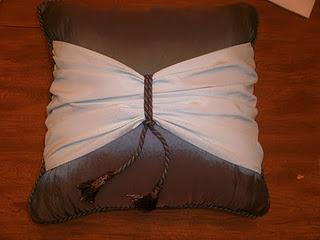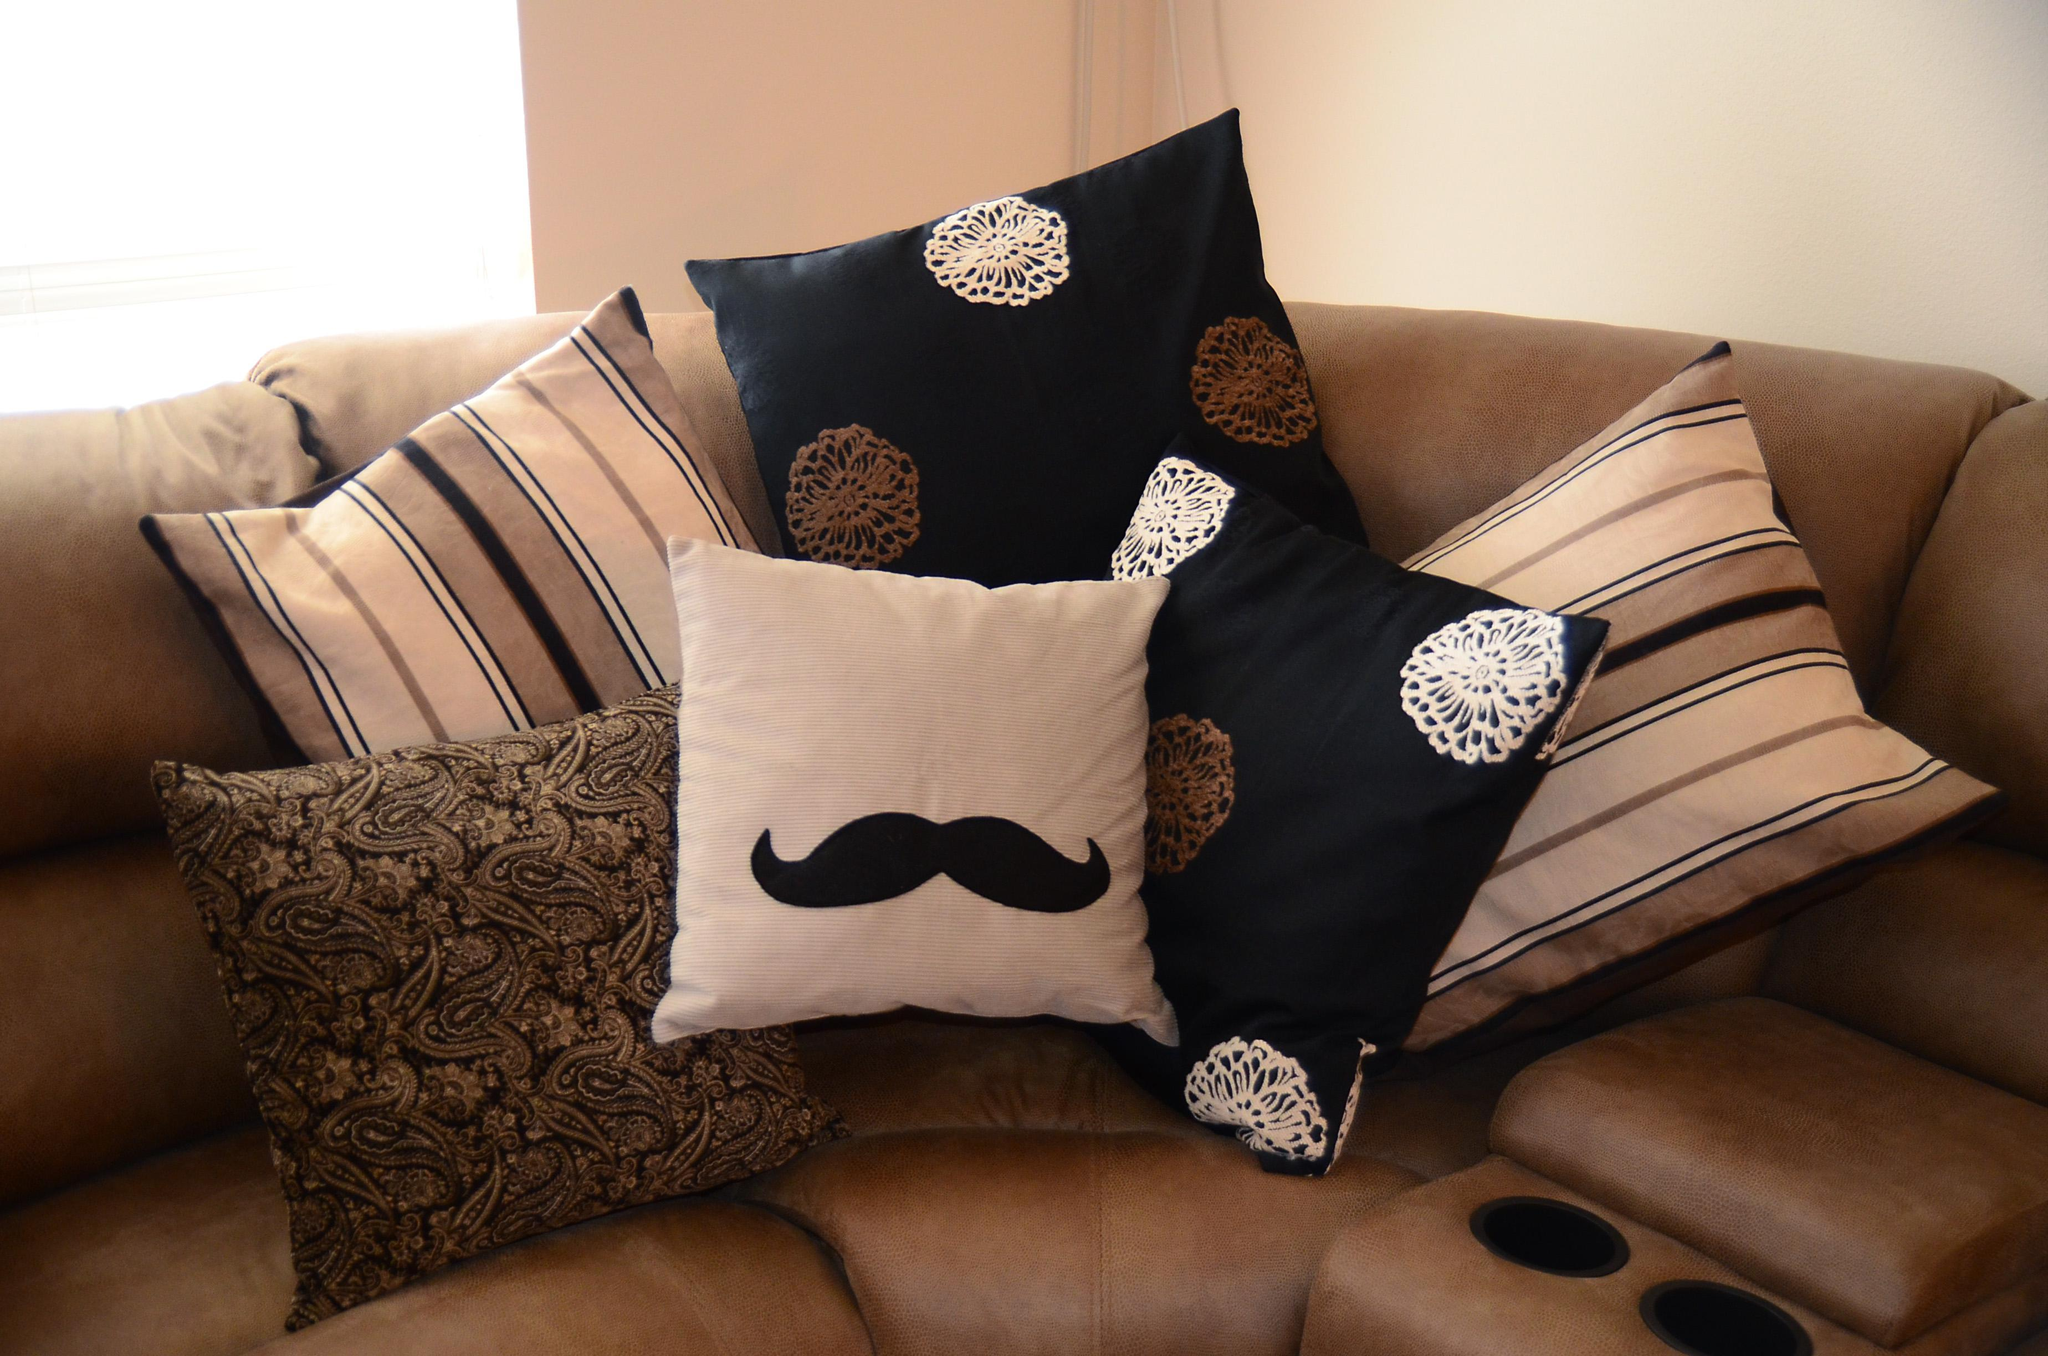The first image is the image on the left, the second image is the image on the right. For the images displayed, is the sentence "The left image contains at least five pillows." factually correct? Answer yes or no. No. The first image is the image on the left, the second image is the image on the right. Assess this claim about the two images: "A brown sofa holds two pillows decorated with round doily shapes on a dark background.". Correct or not? Answer yes or no. Yes. 